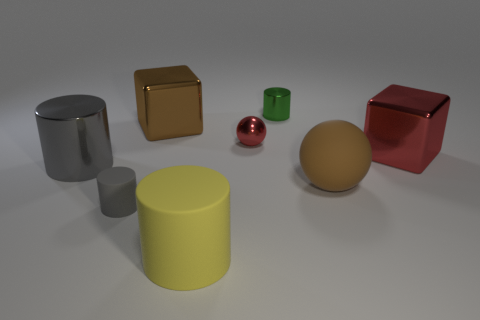Subtract 1 cylinders. How many cylinders are left? 3 Add 1 big brown shiny cubes. How many objects exist? 9 Subtract all red cylinders. Subtract all blue blocks. How many cylinders are left? 4 Subtract all balls. How many objects are left? 6 Add 5 cylinders. How many cylinders are left? 9 Add 3 large gray things. How many large gray things exist? 4 Subtract 0 yellow spheres. How many objects are left? 8 Subtract all big shiny cylinders. Subtract all big cubes. How many objects are left? 5 